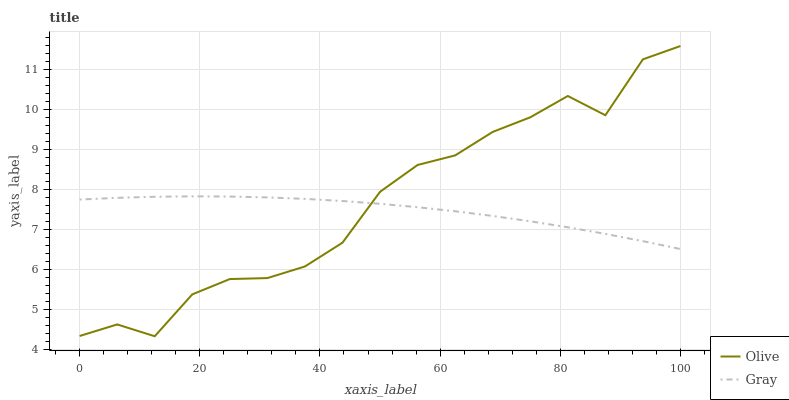Does Gray have the minimum area under the curve?
Answer yes or no. Yes. Does Olive have the maximum area under the curve?
Answer yes or no. Yes. Does Gray have the maximum area under the curve?
Answer yes or no. No. Is Gray the smoothest?
Answer yes or no. Yes. Is Olive the roughest?
Answer yes or no. Yes. Is Gray the roughest?
Answer yes or no. No. Does Olive have the lowest value?
Answer yes or no. Yes. Does Gray have the lowest value?
Answer yes or no. No. Does Olive have the highest value?
Answer yes or no. Yes. Does Gray have the highest value?
Answer yes or no. No. Does Olive intersect Gray?
Answer yes or no. Yes. Is Olive less than Gray?
Answer yes or no. No. Is Olive greater than Gray?
Answer yes or no. No. 